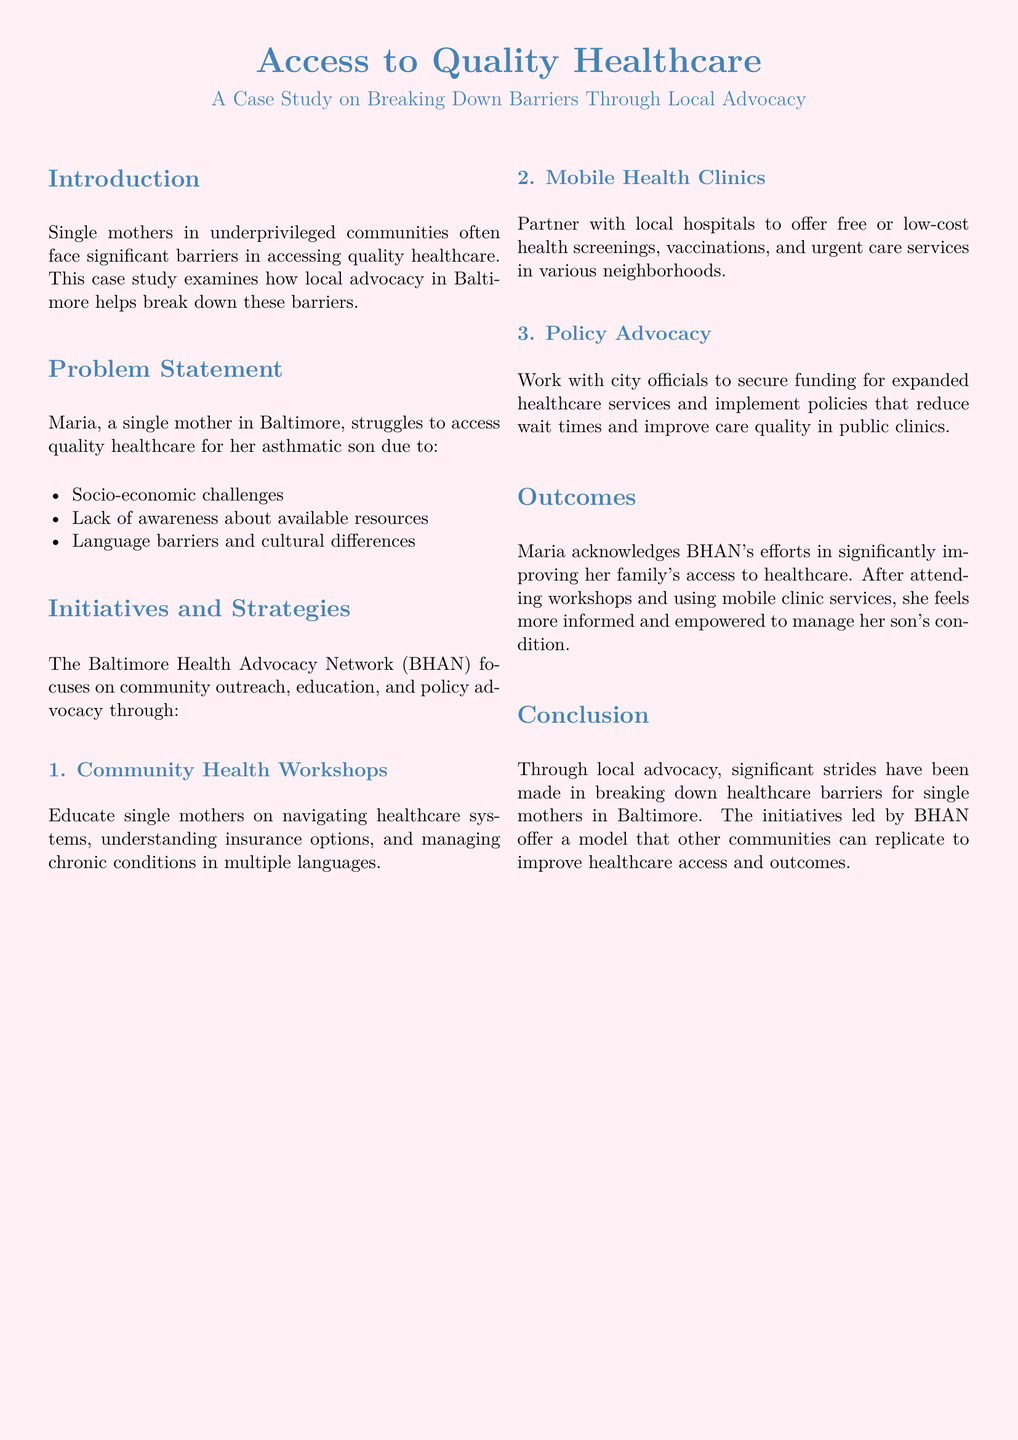What is the primary focus of the Baltimore Health Advocacy Network? The primary focus of BHAN is community outreach, education, and policy advocacy.
Answer: Community outreach, education, and policy advocacy Who is the single mother mentioned in the case study? The case study mentions Maria as the single mother in Baltimore.
Answer: Maria What chronic condition does Maria's son suffer from? Maria's son suffers from asthma, which is specified in the problem statement.
Answer: Asthma Which initiative educates single mothers about healthcare systems? The initiative that educates single mothers is the Community Health Workshops.
Answer: Community Health Workshops What was one outcome of attending BHAN workshops for Maria? Maria felt more informed and empowered to manage her son's condition after attending the workshops.
Answer: More informed and empowered What type of services do mobile health clinics provide? Mobile health clinics provide free or low-cost health screenings, vaccinations, and urgent care services.
Answer: Free or low-cost health screenings, vaccinations, and urgent care services What is one challenge mentioned that hinders access to healthcare? One challenge mentioned is socio-economic challenges faced by single mothers.
Answer: Socio-economic challenges What does BHAN work on with city officials? BHAN works with city officials to secure funding for expanded healthcare services.
Answer: Securing funding for expanded healthcare services 